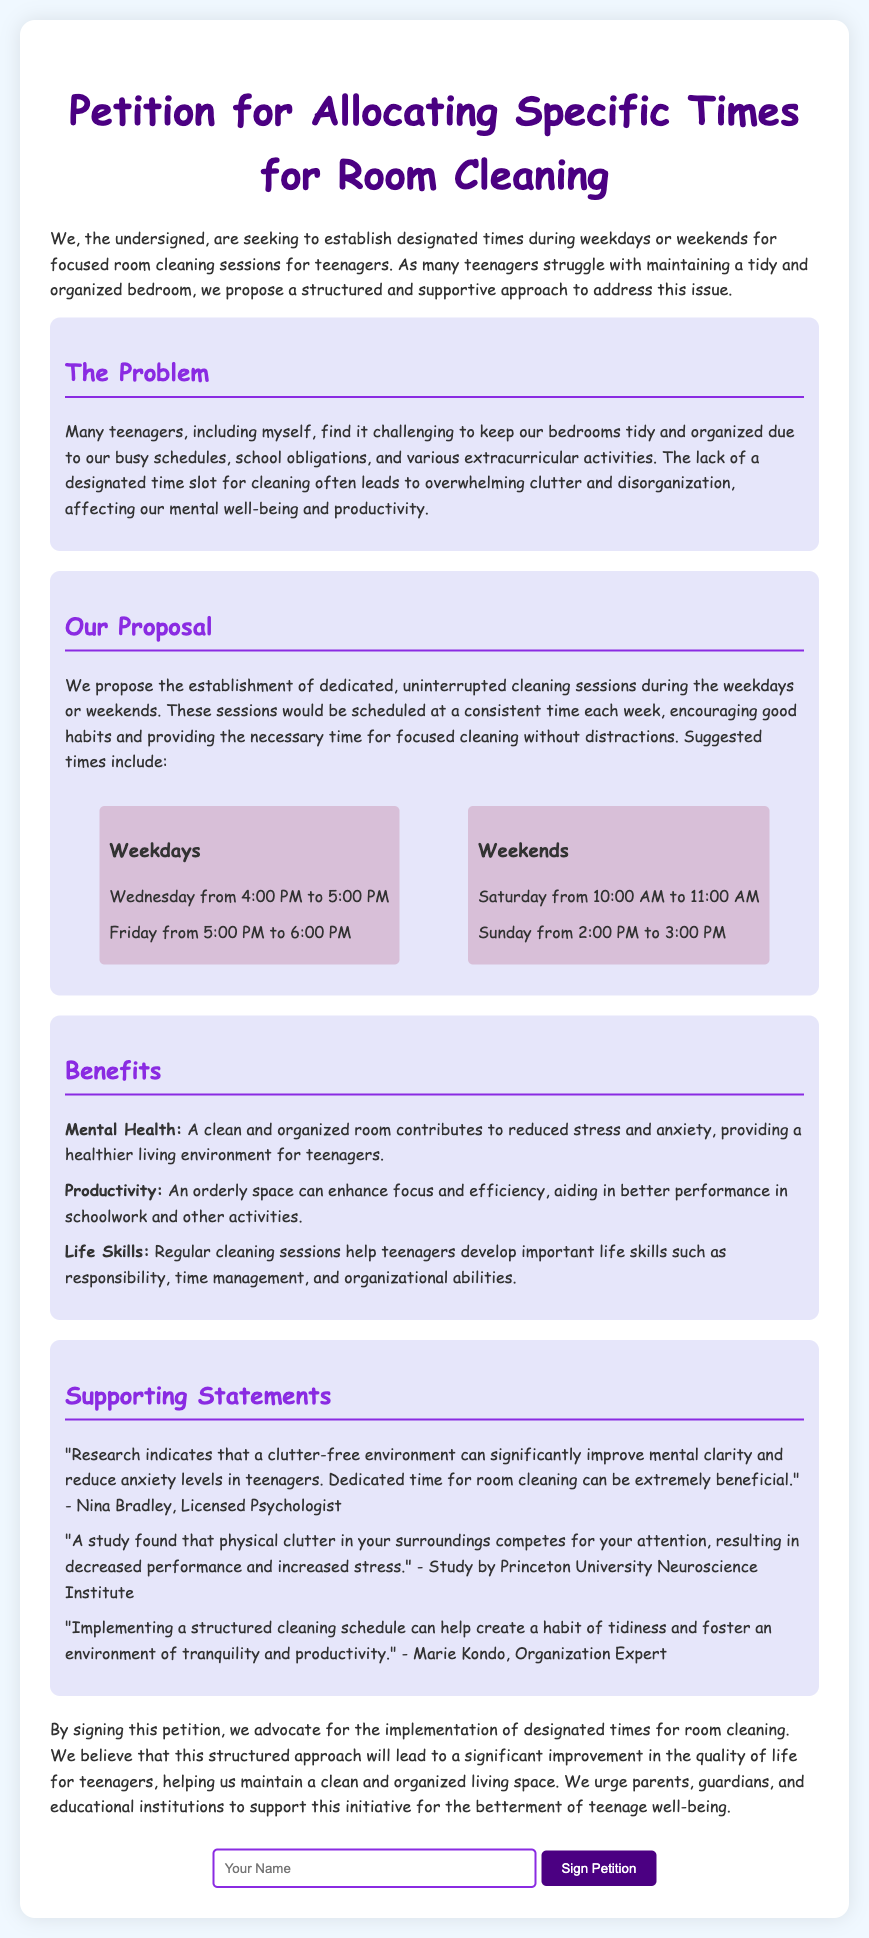What is the main purpose of the petition? The petition aims to establish designated times for focused room cleaning sessions for teenagers.
Answer: Establish designated times for focused room cleaning sessions How many times are suggested for weekdays? The document lists specific times for cleaning on weekdays: two times.
Answer: Two times What day is proposed for cleaning at 4:00 PM? The proposed cleaning time at 4:00 PM is on Wednesday.
Answer: Wednesday What is one benefit of having a clean room mentioned in the petition? The petition states that a clean room contributes to reduced stress and anxiety.
Answer: Reduced stress and anxiety Who is quoted about the impact of clutter on attention? The statement about clutter competing for attention is from a study by Princeton University Neuroscience Institute.
Answer: Princeton University Neuroscience Institute What are the suggested cleaning times on weekends? On weekends, cleaning is suggested for Saturday from 10:00 AM to 11:00 AM and Sunday from 2:00 PM to 3:00 PM.
Answer: Saturday from 10:00 AM to 11:00 AM, Sunday from 2:00 PM to 3:00 PM How does the petition suggest cleaning sessions will help teenagers? The petition mentions that regular cleaning sessions help develop important life skills such as responsibility and time management.
Answer: Develop important life skills such as responsibility and time management What color are the section headers of the document? The section headers are colored with a specific shade of purple.
Answer: Purple 